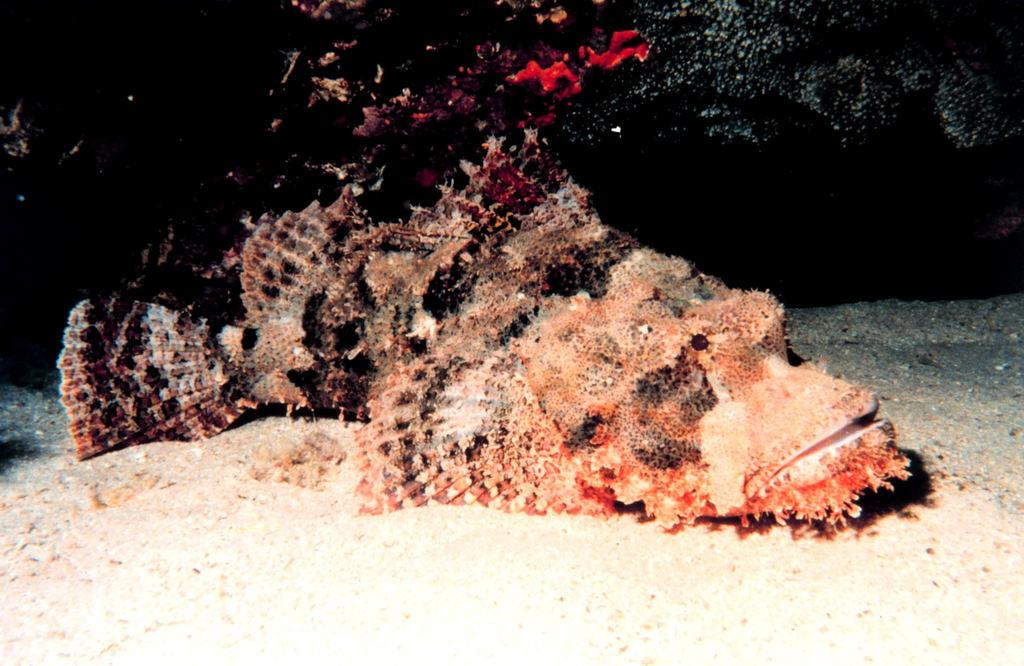What type of fish is in the image? There is a rock fish in the image. Where is the rock fish located? The rock fish is in the water. What type of terrain can be seen at the bottom of the image? There is sand visible at the bottom of the image. What caption would best describe the image? The image does not have a caption, so it cannot be determined what caption would best describe it. What type of pleasure can be derived from the image? The image does not depict any activity or situation that would suggest a specific type of pleasure. Is there a chicken present in the image? No, there is no chicken present in the image; it features a rock fish in the water. 